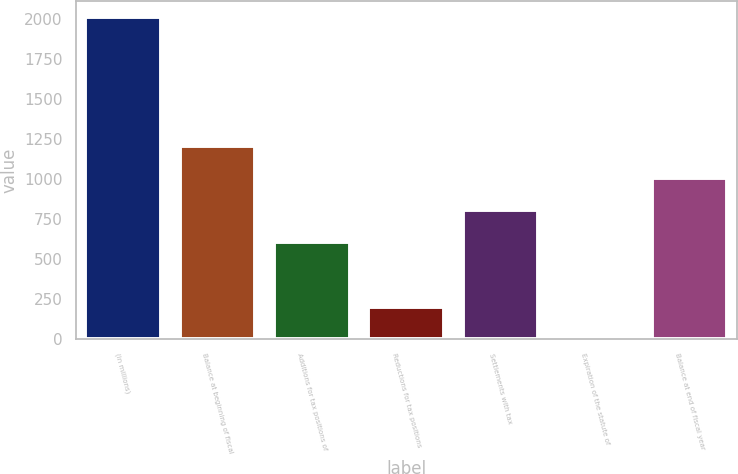Convert chart to OTSL. <chart><loc_0><loc_0><loc_500><loc_500><bar_chart><fcel>(in millions)<fcel>Balance at beginning of fiscal<fcel>Additions for tax positions of<fcel>Reductions for tax positions<fcel>Settlements with tax<fcel>Expiration of the statute of<fcel>Balance at end of fiscal year<nl><fcel>2012<fcel>1208<fcel>605<fcel>203<fcel>806<fcel>2<fcel>1007<nl></chart> 